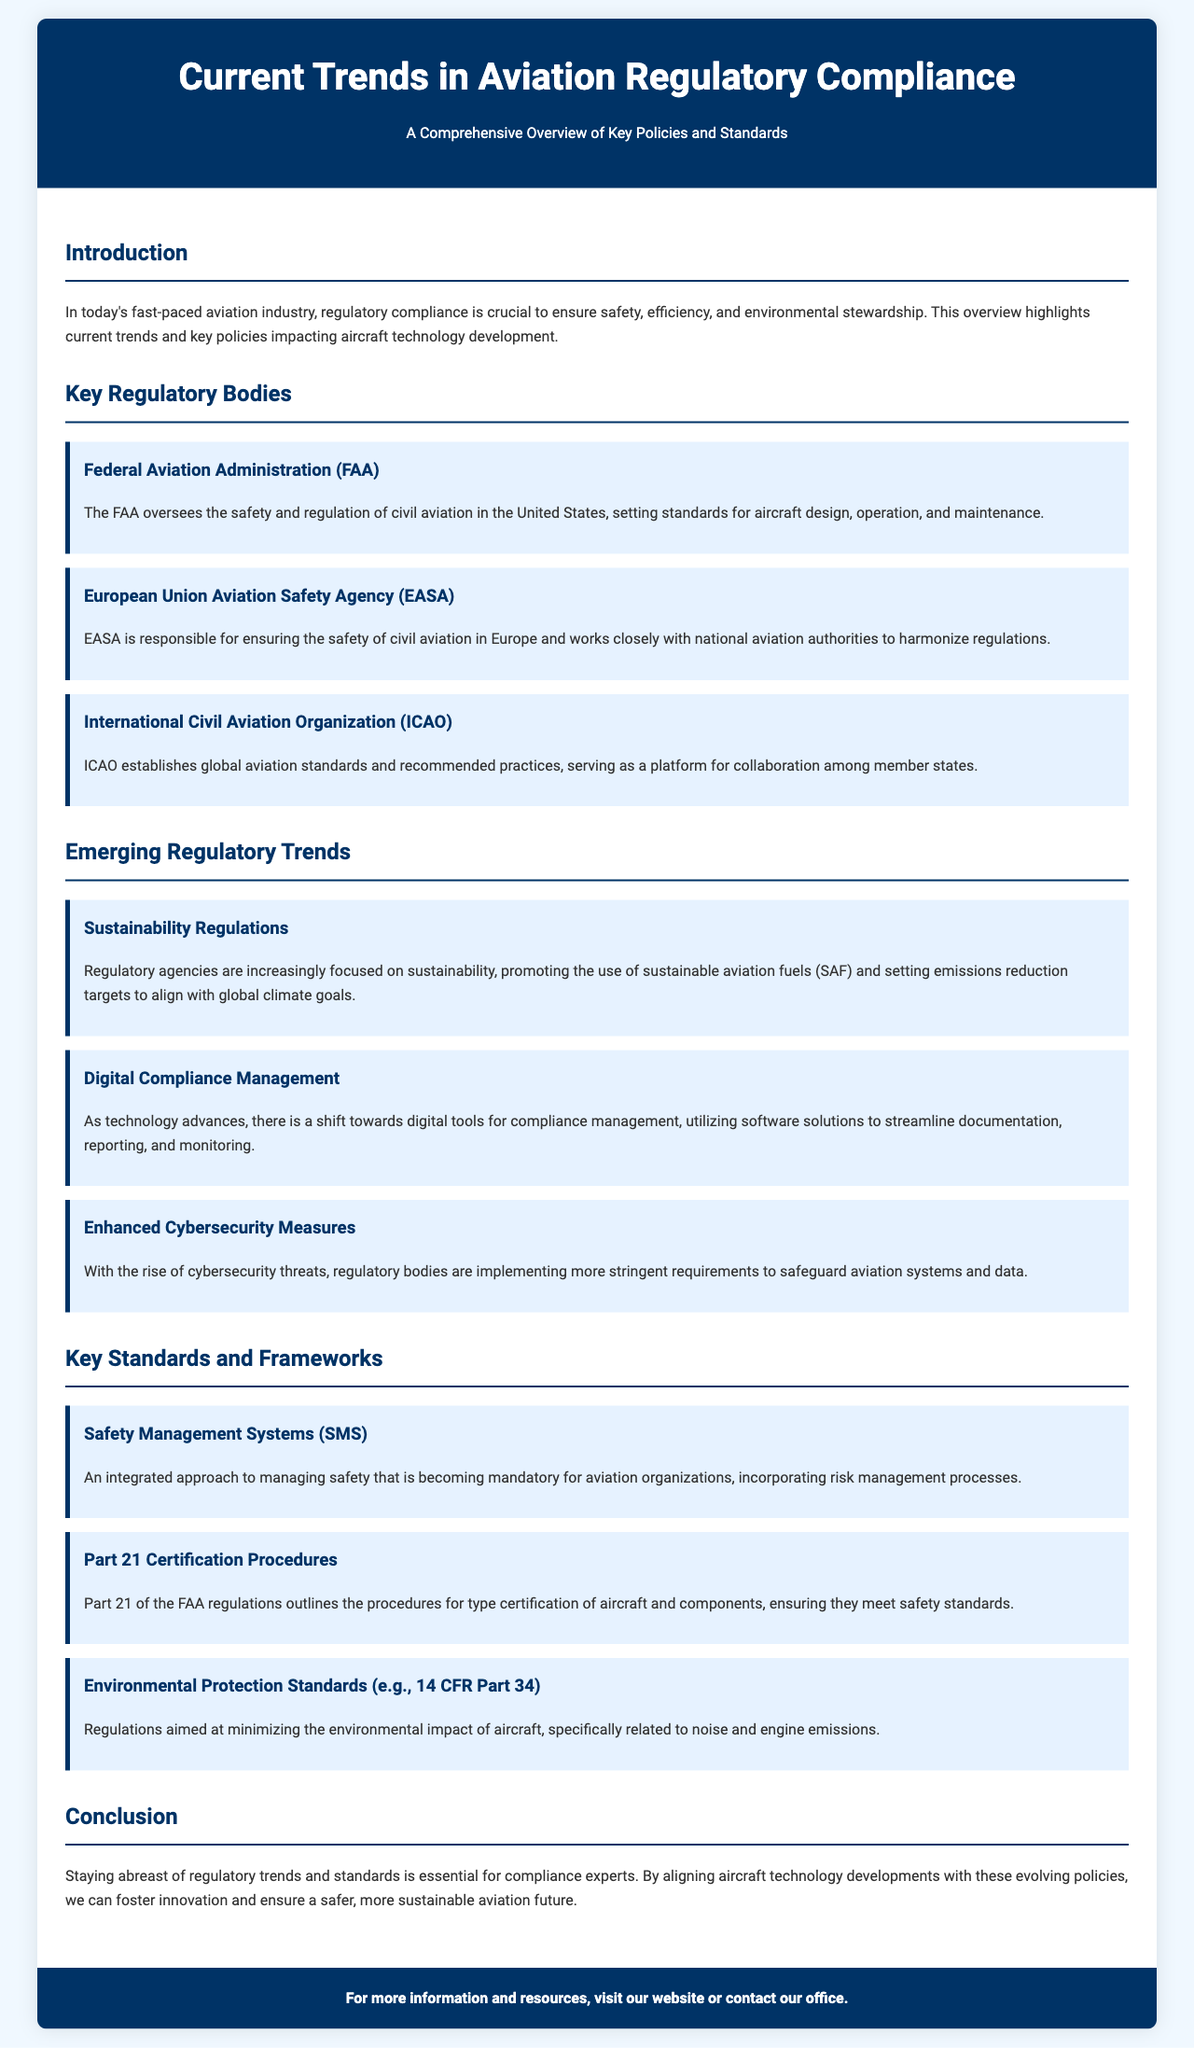What is the main focus of the brochure? The introduction highlights the main focus of the brochure, which is on regulatory compliance in the aviation industry.
Answer: Regulatory compliance Which regulatory body oversees civil aviation safety in the United States? The brochure provides specific names of regulatory bodies, identifying the FAA as the relevant U.S. organization.
Answer: Federal Aviation Administration (FAA) What is a trend related to sustainability mentioned in the document? The emerging trends section outlines sustainability regulations aimed at promoting sustainable aviation fuels and emissions reduction.
Answer: Sustainability Regulations What does SMS stand for in the context of aviation standards? The key standards section mentions SMS as an important safety management standard.
Answer: Safety Management Systems (SMS) How many regulatory bodies are mentioned in the brochure? The document lists three regulatory bodies in its key section.
Answer: Three What kind of tools are being used for compliance management according to the trends? The brochure notes that digital tools are being adopted for compliance management purposes.
Answer: Digital tools What is the purpose of Part 21 certification procedures? The section on key standards explains that Part 21 outlines procedures for type certification of aircraft and components.
Answer: Type certification What does ICAO stand for? The key regulatory bodies section acronyms the International Civil Aviation Organization, where ICAO is used.
Answer: ICAO Which regulatory body works to harmonize regulations within Europe? The brochure specifies EASA as the body responsible for harmonizing aviation regulations in Europe.
Answer: European Union Aviation Safety Agency (EASA) 